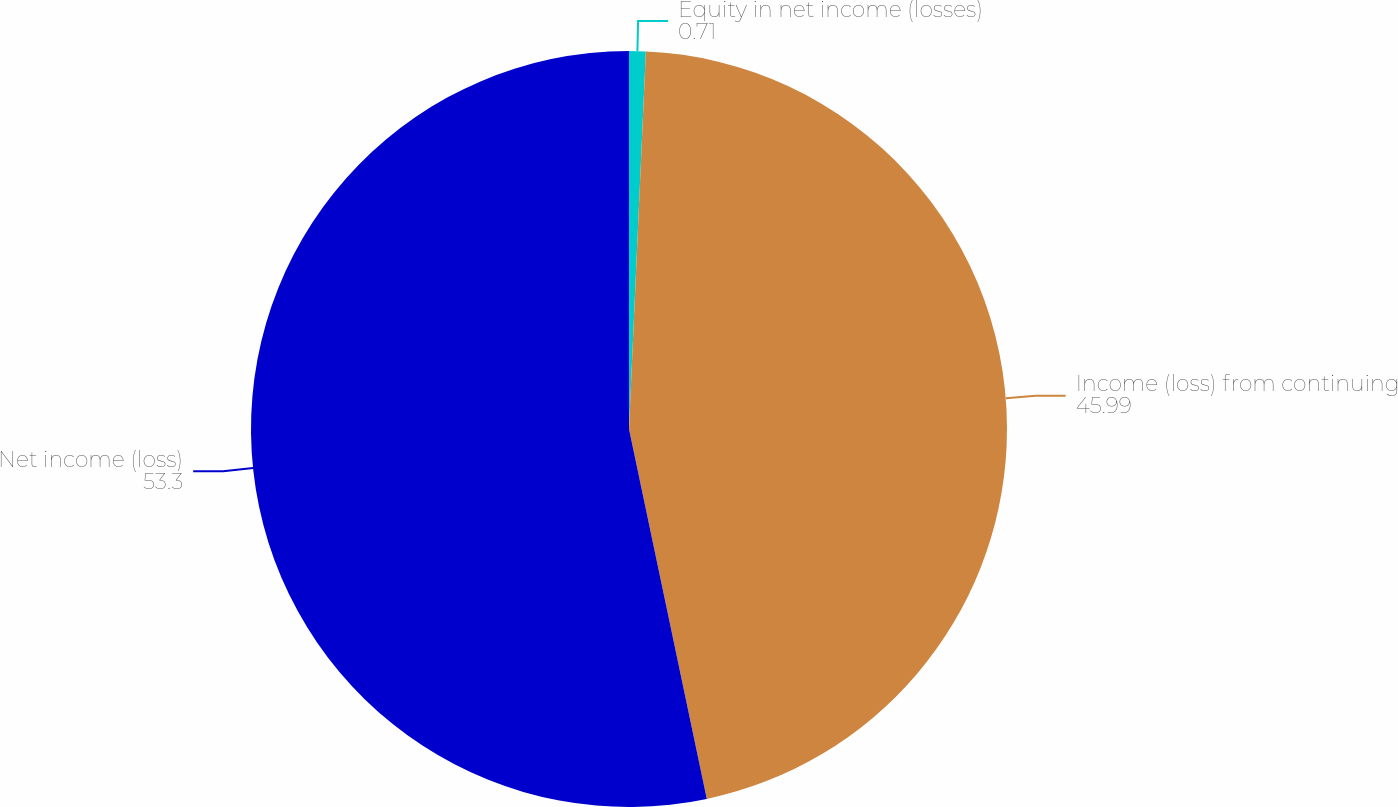<chart> <loc_0><loc_0><loc_500><loc_500><pie_chart><fcel>Equity in net income (losses)<fcel>Income (loss) from continuing<fcel>Net income (loss)<nl><fcel>0.71%<fcel>45.99%<fcel>53.3%<nl></chart> 